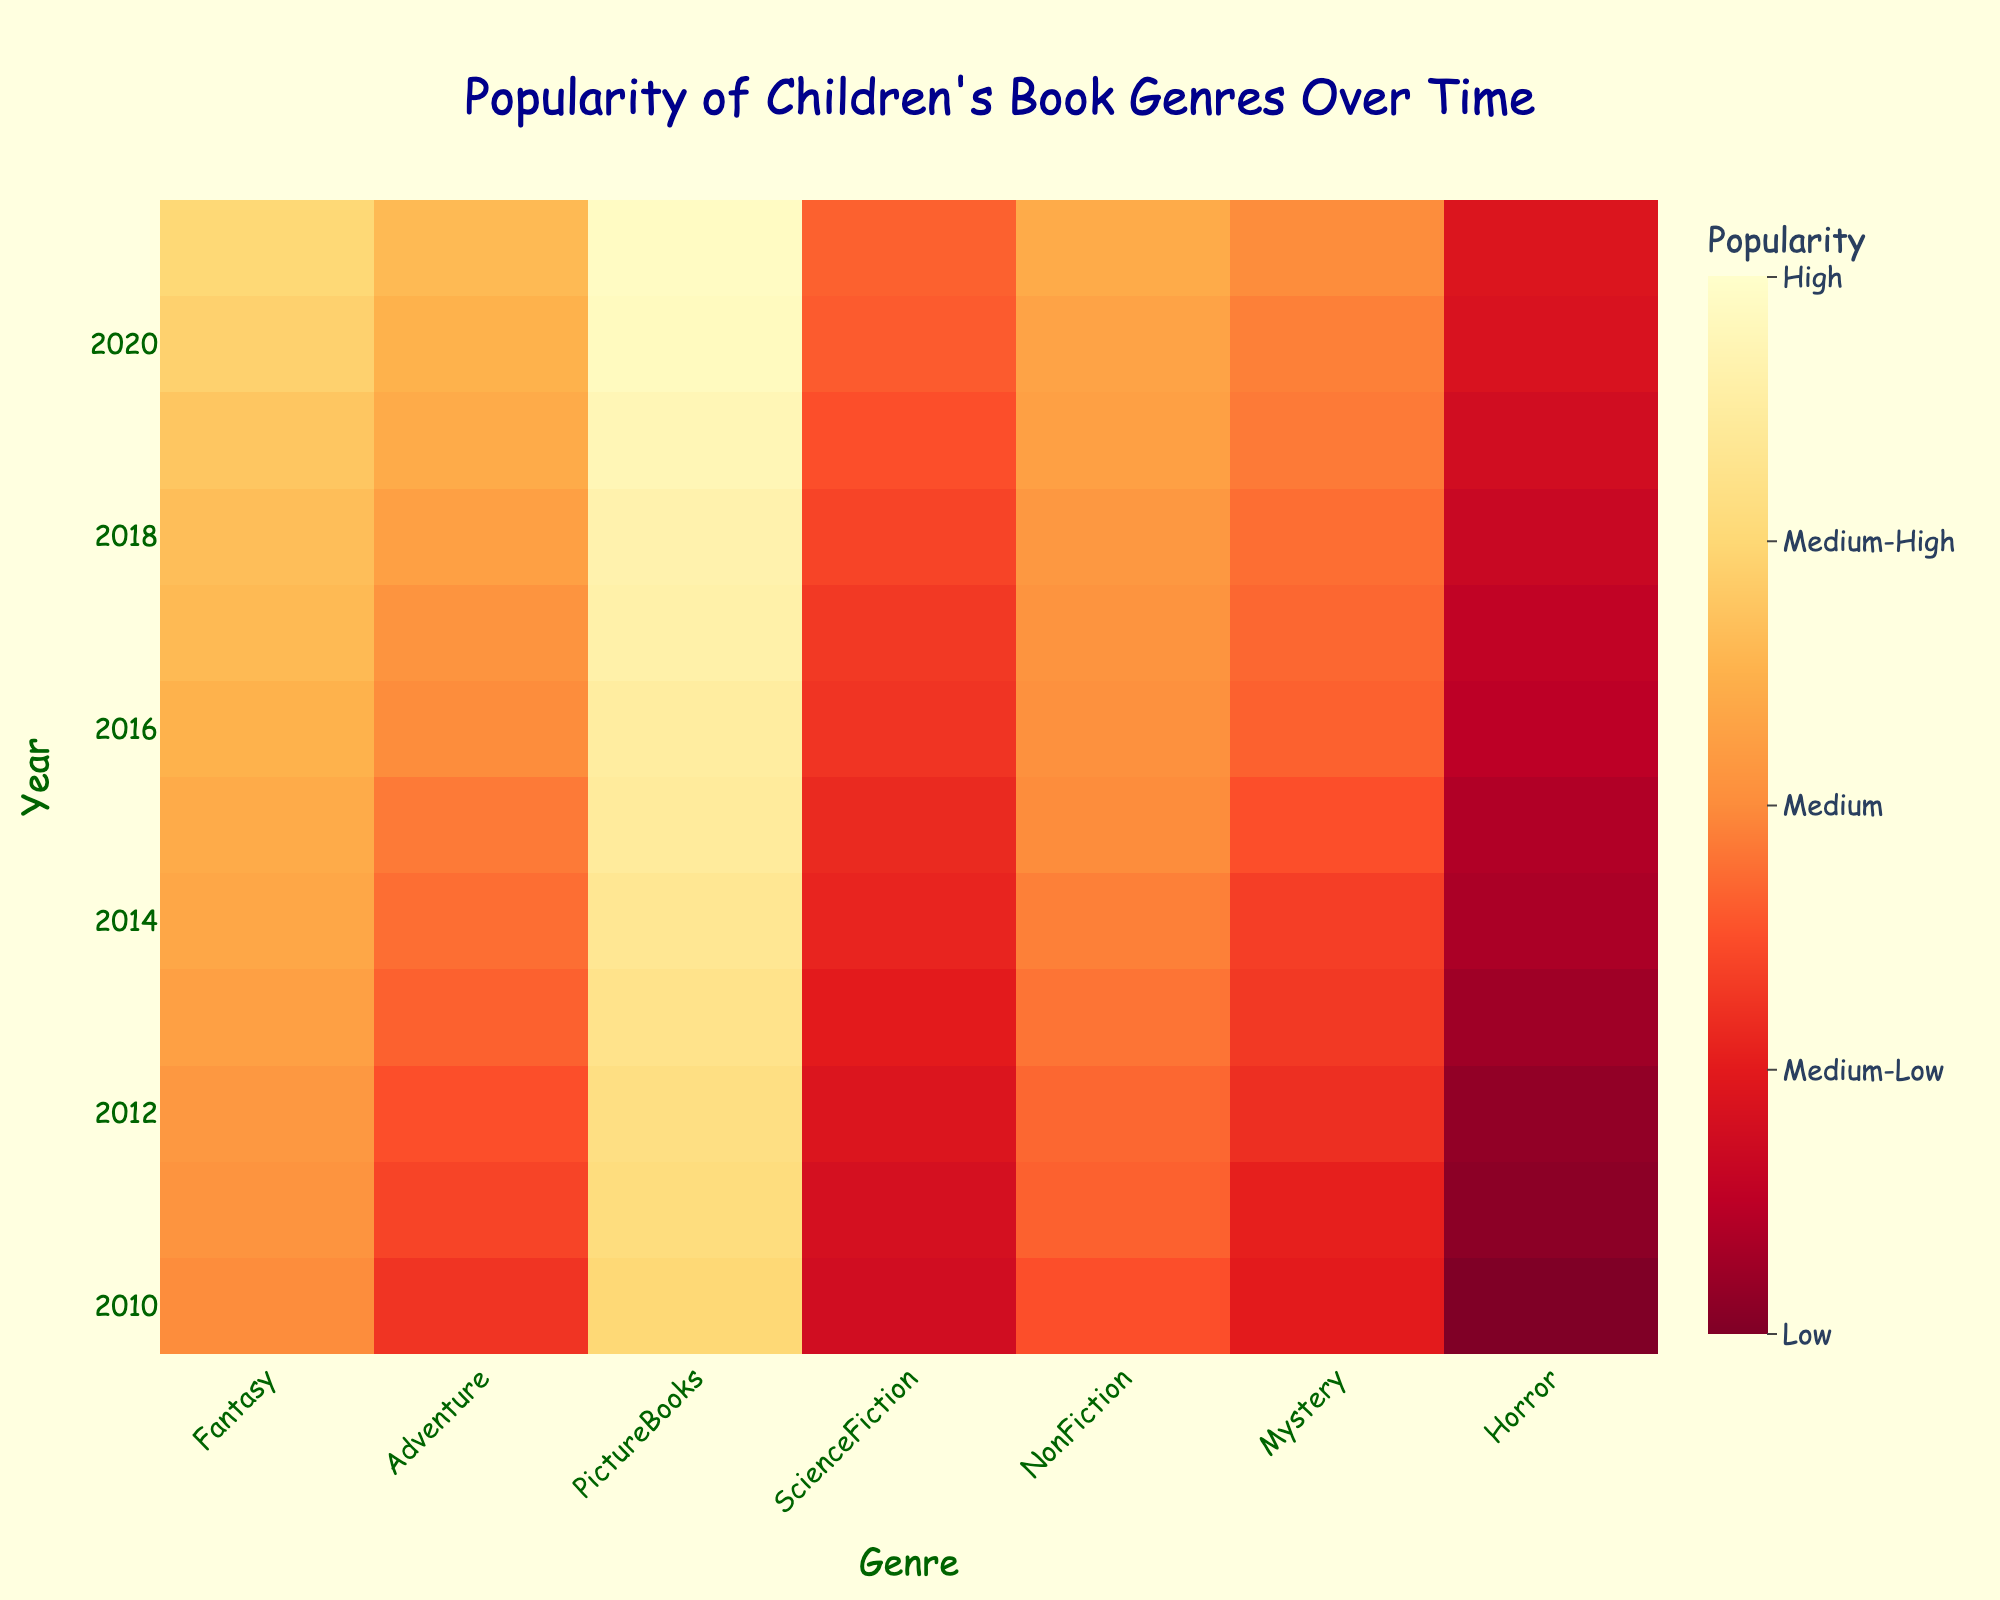What's the title of the figure? The title of the figure is located at the top center of the image.
Answer: Popularity of Children's Book Genres Over Time How many genres of children's books are represented in the heatmap? The x-axis lists the different genres of children's books. Count each distinct genre label.
Answer: 7 Which genre was the most popular in 2021? To find the most popular genre in 2021, look at the row for 2021 and identify the highest value among the genres.
Answer: PictureBooks What's the general trend in popularity for the Fantasy genre from 2010 to 2021? Look at the values for the Fantasy genre from 2010 to 2021 and observe if they are increasing, decreasing, or remaining constant over time.
Answer: Increasing In which year did NonFiction become more popular than Mystery for the first time? Compare the values of NonFiction and Mystery year by year and identify the first instance where NonFiction has a higher value than Mystery.
Answer: 2011 Which genre had the least popularity in 2013? In the 2013 row, find the column with the smallest value.
Answer: Horror What's the average popularity of PictureBooks from 2010 to 2021? Sum up the PictureBooks values for each year from 2010 to 2021, then divide by the number of years (12) to find the average.
Answer: (80 + 82 + 83 + 85 + 87 + 89 + 90 + 92 + 93 + 95 + 97 + 98) / 12 = 89.5 By how much did the popularity of Adventure books increase from 2010 to 2021? Subtract the 2010 value for Adventure from the 2021 value to find the increase.
Answer: 72 - 45 = 27 Which genre showed the highest increase in popularity from 2010 to 2021? Calculate the increase in popularity for each genre from 2010 to 2021 and identify the genre with the highest increase.
Answer: PictureBooks During which year did Horror show a value of 30? Identify the year in the Horror genre column where the value is 30.
Answer: 2016 